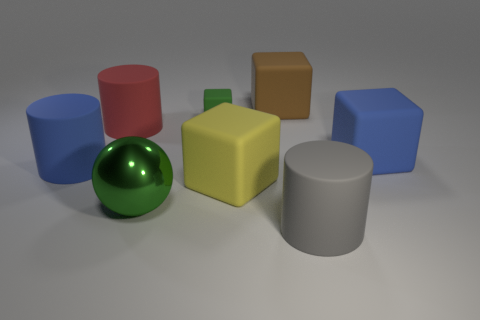There is a big object that is the same color as the tiny block; what is its shape?
Give a very brief answer. Sphere. There is a matte object that is the same color as the big metallic sphere; what size is it?
Your answer should be very brief. Small. How many things are either big blue matte objects or small rubber blocks?
Your answer should be very brief. 3. Is the color of the tiny matte object the same as the metal ball?
Make the answer very short. Yes. Is there any other thing that is the same size as the red matte cylinder?
Provide a short and direct response. Yes. There is a blue rubber thing that is behind the blue matte object that is to the left of the blue cube; what is its shape?
Provide a succinct answer. Cube. Are there fewer tiny blocks than small purple metal spheres?
Keep it short and to the point. No. There is a object that is right of the brown block and behind the big blue matte cylinder; what size is it?
Provide a short and direct response. Large. Do the green metal ball and the brown matte thing have the same size?
Make the answer very short. Yes. Is the color of the thing that is on the left side of the big red thing the same as the tiny thing?
Offer a terse response. No. 